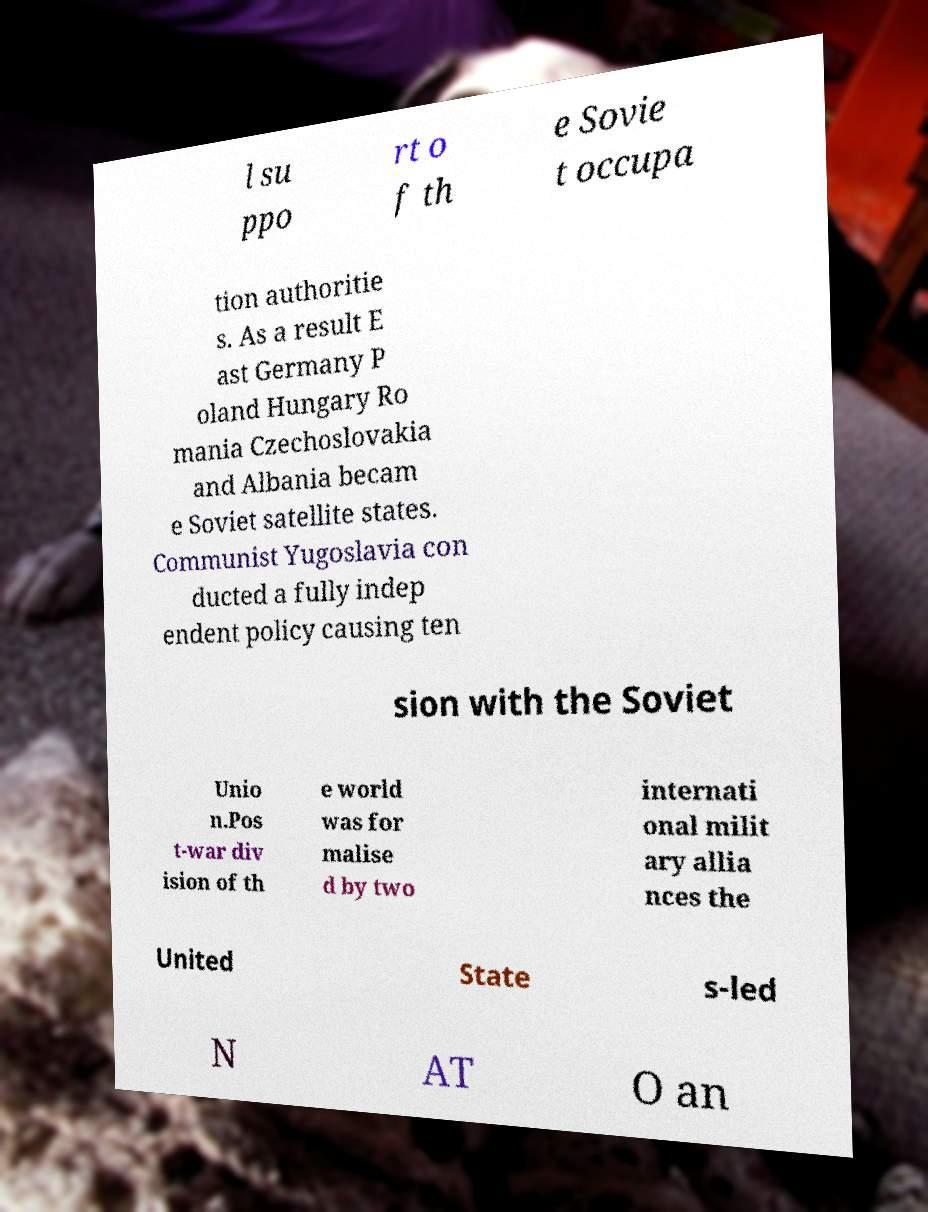There's text embedded in this image that I need extracted. Can you transcribe it verbatim? l su ppo rt o f th e Sovie t occupa tion authoritie s. As a result E ast Germany P oland Hungary Ro mania Czechoslovakia and Albania becam e Soviet satellite states. Communist Yugoslavia con ducted a fully indep endent policy causing ten sion with the Soviet Unio n.Pos t-war div ision of th e world was for malise d by two internati onal milit ary allia nces the United State s-led N AT O an 